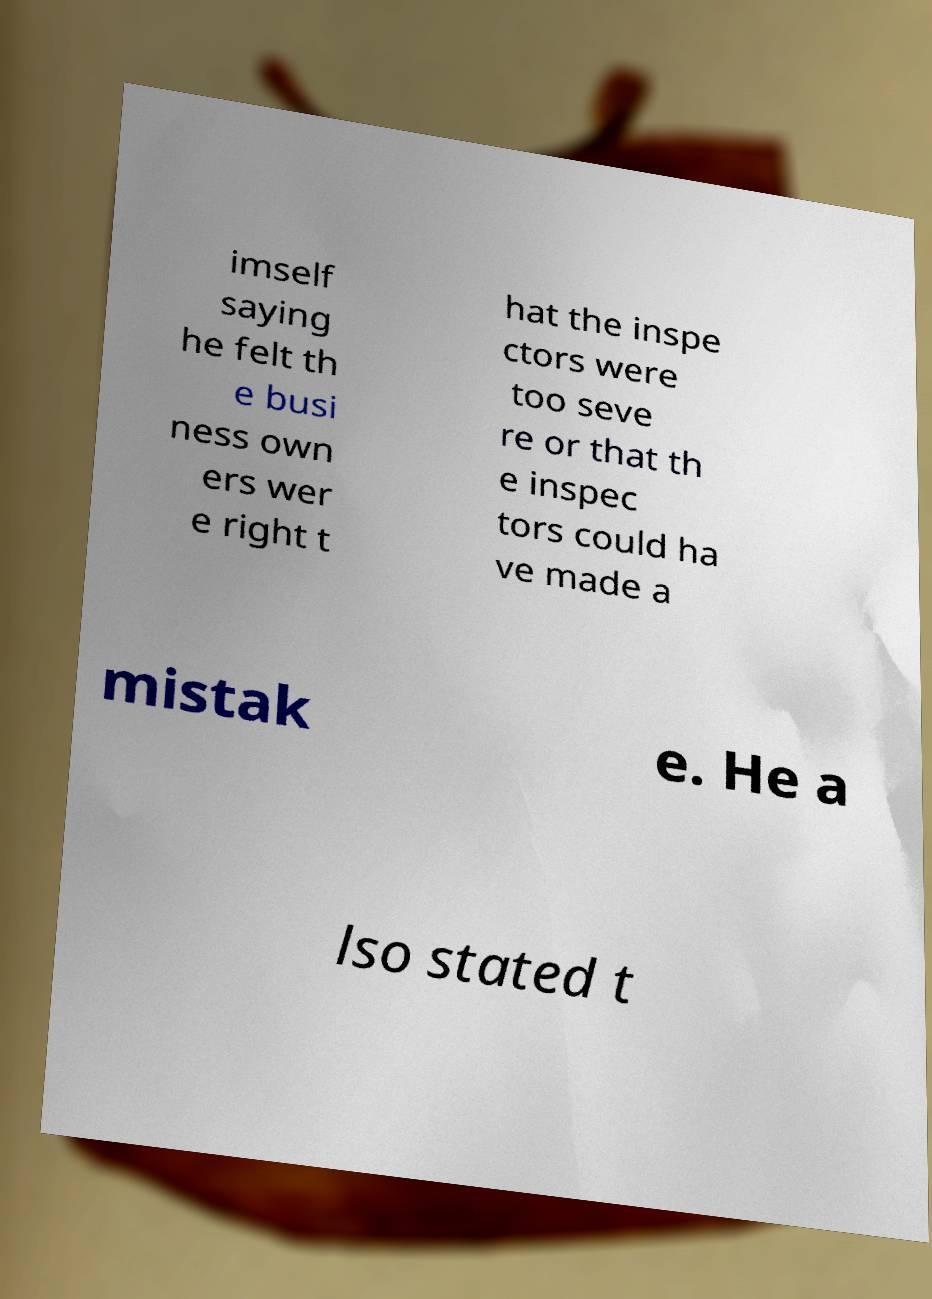Can you read and provide the text displayed in the image?This photo seems to have some interesting text. Can you extract and type it out for me? imself saying he felt th e busi ness own ers wer e right t hat the inspe ctors were too seve re or that th e inspec tors could ha ve made a mistak e. He a lso stated t 